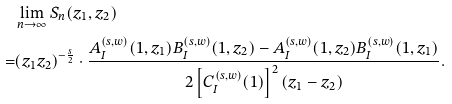<formula> <loc_0><loc_0><loc_500><loc_500>& \lim _ { n \to \infty } S _ { n } ( z _ { 1 } , z _ { 2 } ) \\ = & ( z _ { 1 } z _ { 2 } ) ^ { - \frac { s } { 2 } } \cdot \frac { A _ { I } ^ { ( s , w ) } ( 1 , z _ { 1 } ) B _ { I } ^ { ( s , w ) } ( 1 , z _ { 2 } ) - A _ { I } ^ { ( s , w ) } ( 1 , z _ { 2 } ) B _ { I } ^ { ( s , w ) } ( 1 , z _ { 1 } ) } { 2 \left [ C _ { I } ^ { ( s , w ) } ( 1 ) \right ] ^ { 2 } ( z _ { 1 } - z _ { 2 } ) } .</formula> 